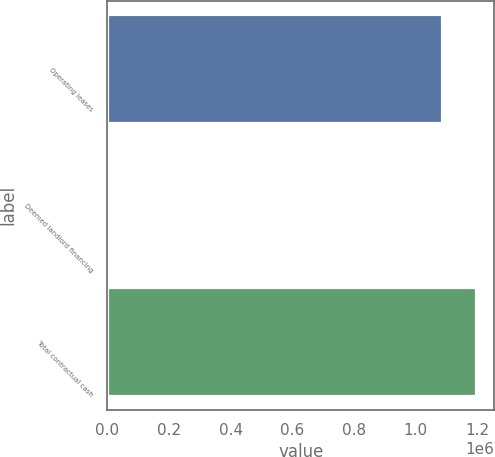Convert chart. <chart><loc_0><loc_0><loc_500><loc_500><bar_chart><fcel>Operating leases<fcel>Deemed landlord financing<fcel>Total contractual cash<nl><fcel>1.08622e+06<fcel>7756<fcel>1.19618e+06<nl></chart> 